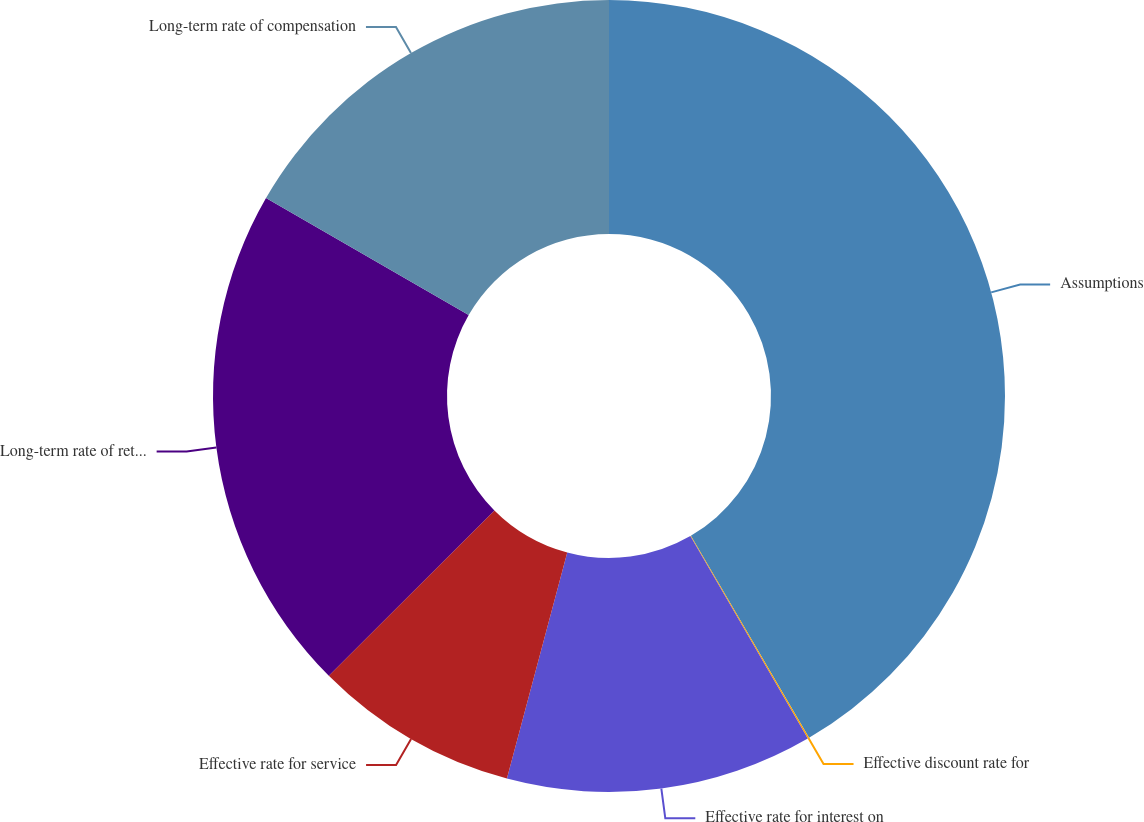Convert chart. <chart><loc_0><loc_0><loc_500><loc_500><pie_chart><fcel>Assumptions<fcel>Effective discount rate for<fcel>Effective rate for interest on<fcel>Effective rate for service<fcel>Long-term rate of return on<fcel>Long-term rate of compensation<nl><fcel>41.57%<fcel>0.06%<fcel>12.52%<fcel>8.36%<fcel>20.82%<fcel>16.67%<nl></chart> 